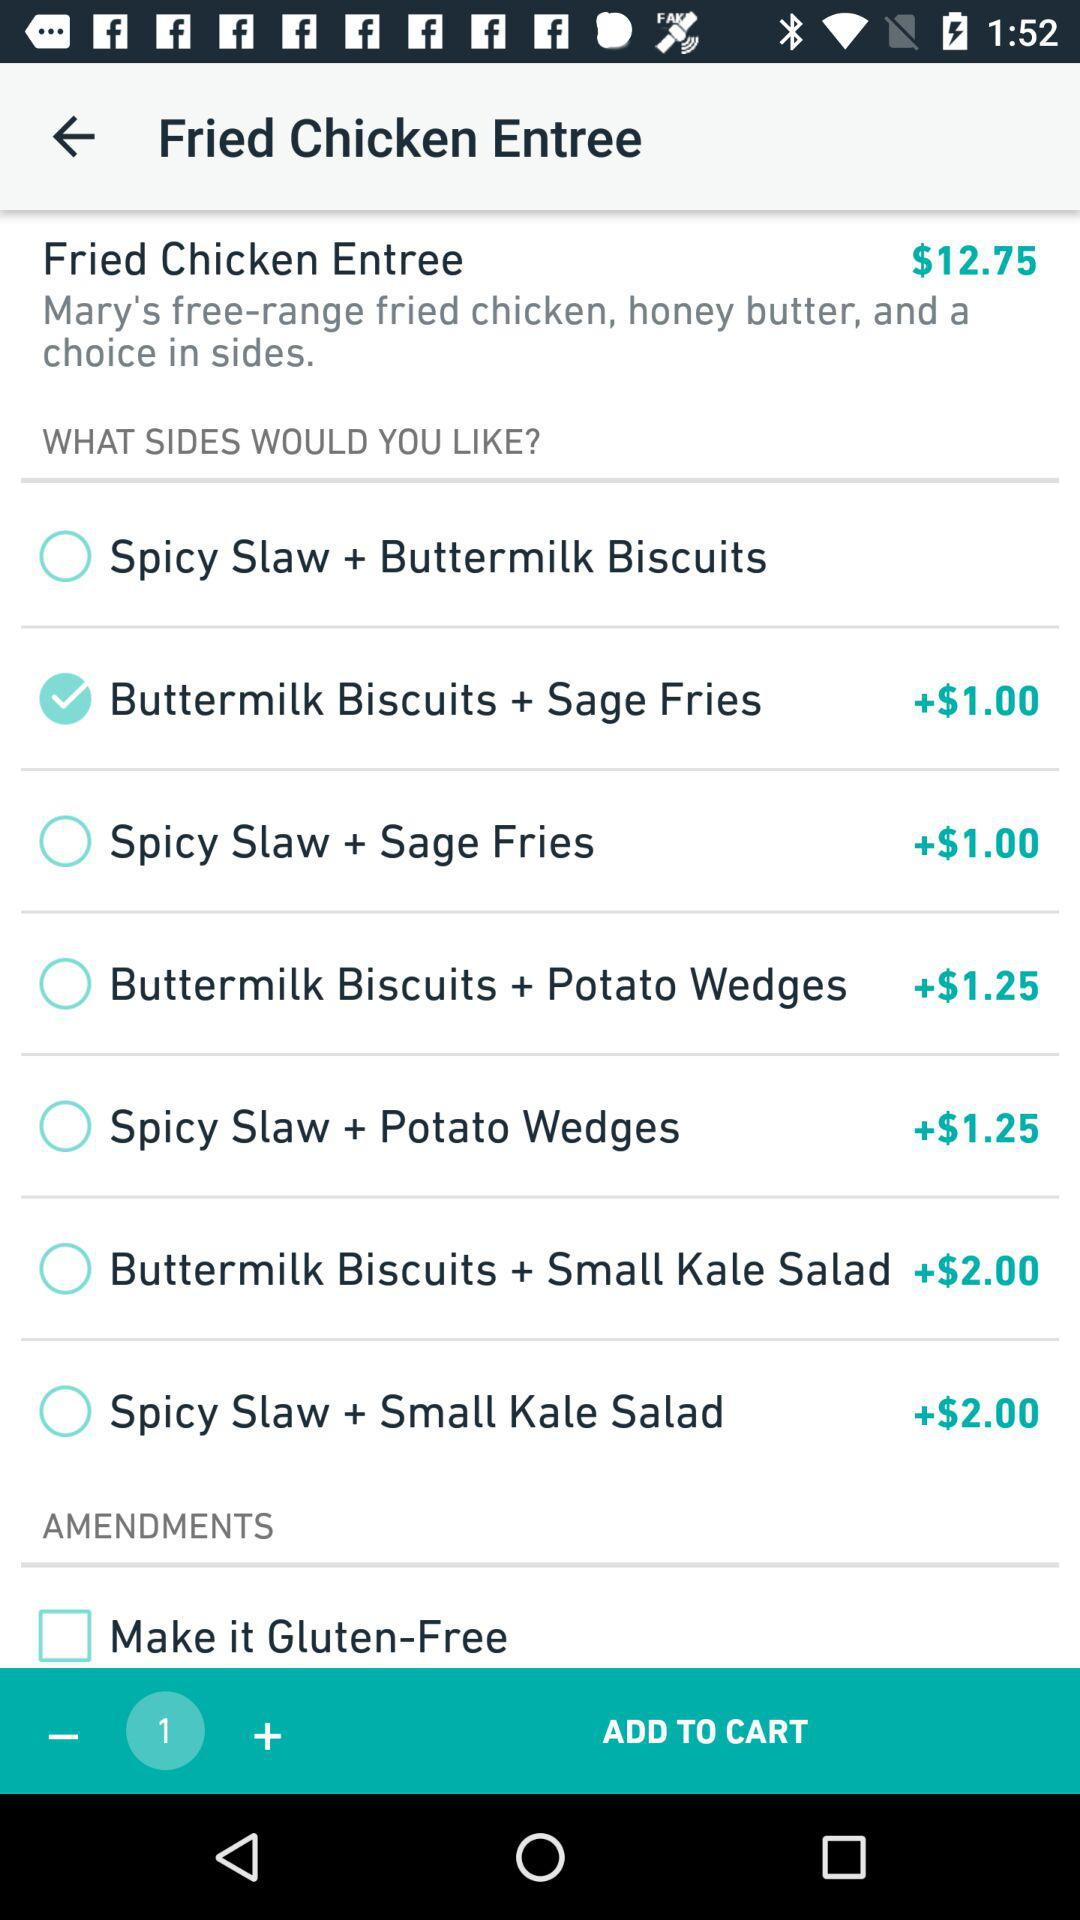What is the price of the "Spicy Slaw + Potato Wedges"? The price of the "Spicy Slaw + Potato Wedges" is $1.25. 